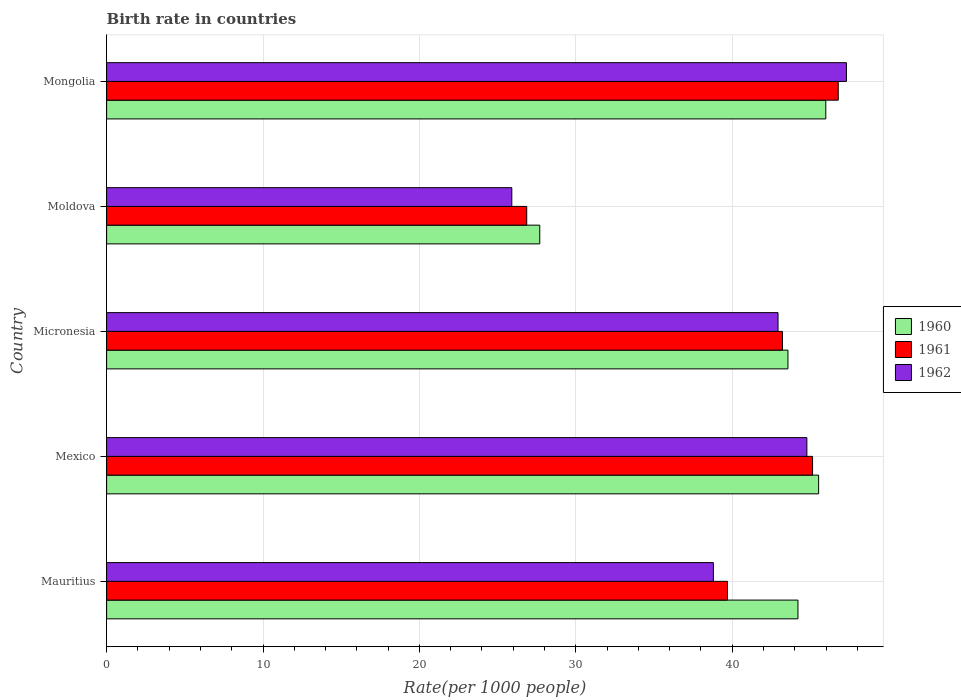How many different coloured bars are there?
Provide a short and direct response. 3. How many groups of bars are there?
Give a very brief answer. 5. What is the label of the 3rd group of bars from the top?
Your answer should be very brief. Micronesia. In how many cases, is the number of bars for a given country not equal to the number of legend labels?
Keep it short and to the point. 0. What is the birth rate in 1961 in Micronesia?
Your answer should be very brief. 43.22. Across all countries, what is the maximum birth rate in 1961?
Keep it short and to the point. 46.78. Across all countries, what is the minimum birth rate in 1961?
Offer a very short reply. 26.86. In which country was the birth rate in 1961 maximum?
Offer a terse response. Mongolia. In which country was the birth rate in 1961 minimum?
Provide a succinct answer. Moldova. What is the total birth rate in 1962 in the graph?
Offer a terse response. 199.73. What is the difference between the birth rate in 1962 in Moldova and that in Mongolia?
Make the answer very short. -21.4. What is the difference between the birth rate in 1960 in Moldova and the birth rate in 1962 in Micronesia?
Provide a succinct answer. -15.24. What is the average birth rate in 1962 per country?
Provide a short and direct response. 39.95. What is the difference between the birth rate in 1960 and birth rate in 1962 in Mexico?
Your answer should be very brief. 0.75. What is the ratio of the birth rate in 1962 in Moldova to that in Mongolia?
Your answer should be compact. 0.55. Is the difference between the birth rate in 1960 in Moldova and Mongolia greater than the difference between the birth rate in 1962 in Moldova and Mongolia?
Keep it short and to the point. Yes. What is the difference between the highest and the second highest birth rate in 1960?
Make the answer very short. 0.46. What is the difference between the highest and the lowest birth rate in 1960?
Offer a very short reply. 18.29. In how many countries, is the birth rate in 1962 greater than the average birth rate in 1962 taken over all countries?
Offer a terse response. 3. Is the sum of the birth rate in 1960 in Moldova and Mongolia greater than the maximum birth rate in 1961 across all countries?
Your answer should be very brief. Yes. How many bars are there?
Keep it short and to the point. 15. Are the values on the major ticks of X-axis written in scientific E-notation?
Provide a succinct answer. No. Does the graph contain grids?
Ensure brevity in your answer.  Yes. How many legend labels are there?
Offer a very short reply. 3. What is the title of the graph?
Make the answer very short. Birth rate in countries. What is the label or title of the X-axis?
Ensure brevity in your answer.  Rate(per 1000 people). What is the label or title of the Y-axis?
Your response must be concise. Country. What is the Rate(per 1000 people) in 1960 in Mauritius?
Your response must be concise. 44.21. What is the Rate(per 1000 people) of 1961 in Mauritius?
Your answer should be very brief. 39.7. What is the Rate(per 1000 people) of 1962 in Mauritius?
Ensure brevity in your answer.  38.8. What is the Rate(per 1000 people) of 1960 in Mexico?
Provide a short and direct response. 45.53. What is the Rate(per 1000 people) in 1961 in Mexico?
Offer a terse response. 45.14. What is the Rate(per 1000 people) in 1962 in Mexico?
Your answer should be compact. 44.78. What is the Rate(per 1000 people) in 1960 in Micronesia?
Offer a very short reply. 43.57. What is the Rate(per 1000 people) of 1961 in Micronesia?
Your answer should be compact. 43.22. What is the Rate(per 1000 people) in 1962 in Micronesia?
Give a very brief answer. 42.93. What is the Rate(per 1000 people) in 1960 in Moldova?
Your answer should be very brief. 27.7. What is the Rate(per 1000 people) in 1961 in Moldova?
Provide a short and direct response. 26.86. What is the Rate(per 1000 people) in 1962 in Moldova?
Your answer should be compact. 25.91. What is the Rate(per 1000 people) of 1960 in Mongolia?
Your answer should be compact. 45.99. What is the Rate(per 1000 people) in 1961 in Mongolia?
Offer a terse response. 46.78. What is the Rate(per 1000 people) in 1962 in Mongolia?
Your answer should be very brief. 47.31. Across all countries, what is the maximum Rate(per 1000 people) of 1960?
Your answer should be compact. 45.99. Across all countries, what is the maximum Rate(per 1000 people) of 1961?
Your response must be concise. 46.78. Across all countries, what is the maximum Rate(per 1000 people) of 1962?
Provide a succinct answer. 47.31. Across all countries, what is the minimum Rate(per 1000 people) in 1960?
Offer a very short reply. 27.7. Across all countries, what is the minimum Rate(per 1000 people) in 1961?
Your response must be concise. 26.86. Across all countries, what is the minimum Rate(per 1000 people) of 1962?
Provide a short and direct response. 25.91. What is the total Rate(per 1000 people) in 1960 in the graph?
Your answer should be compact. 206.99. What is the total Rate(per 1000 people) in 1961 in the graph?
Make the answer very short. 201.71. What is the total Rate(per 1000 people) of 1962 in the graph?
Ensure brevity in your answer.  199.73. What is the difference between the Rate(per 1000 people) of 1960 in Mauritius and that in Mexico?
Provide a short and direct response. -1.32. What is the difference between the Rate(per 1000 people) in 1961 in Mauritius and that in Mexico?
Provide a succinct answer. -5.44. What is the difference between the Rate(per 1000 people) in 1962 in Mauritius and that in Mexico?
Provide a short and direct response. -5.98. What is the difference between the Rate(per 1000 people) in 1960 in Mauritius and that in Micronesia?
Ensure brevity in your answer.  0.64. What is the difference between the Rate(per 1000 people) of 1961 in Mauritius and that in Micronesia?
Offer a very short reply. -3.52. What is the difference between the Rate(per 1000 people) in 1962 in Mauritius and that in Micronesia?
Provide a succinct answer. -4.13. What is the difference between the Rate(per 1000 people) of 1960 in Mauritius and that in Moldova?
Make the answer very short. 16.51. What is the difference between the Rate(per 1000 people) in 1961 in Mauritius and that in Moldova?
Ensure brevity in your answer.  12.84. What is the difference between the Rate(per 1000 people) in 1962 in Mauritius and that in Moldova?
Your answer should be compact. 12.89. What is the difference between the Rate(per 1000 people) of 1960 in Mauritius and that in Mongolia?
Your answer should be compact. -1.78. What is the difference between the Rate(per 1000 people) of 1961 in Mauritius and that in Mongolia?
Provide a short and direct response. -7.08. What is the difference between the Rate(per 1000 people) of 1962 in Mauritius and that in Mongolia?
Your response must be concise. -8.51. What is the difference between the Rate(per 1000 people) in 1960 in Mexico and that in Micronesia?
Keep it short and to the point. 1.96. What is the difference between the Rate(per 1000 people) of 1961 in Mexico and that in Micronesia?
Your response must be concise. 1.92. What is the difference between the Rate(per 1000 people) in 1962 in Mexico and that in Micronesia?
Offer a terse response. 1.84. What is the difference between the Rate(per 1000 people) in 1960 in Mexico and that in Moldova?
Your answer should be very brief. 17.83. What is the difference between the Rate(per 1000 people) of 1961 in Mexico and that in Moldova?
Ensure brevity in your answer.  18.28. What is the difference between the Rate(per 1000 people) of 1962 in Mexico and that in Moldova?
Make the answer very short. 18.87. What is the difference between the Rate(per 1000 people) of 1960 in Mexico and that in Mongolia?
Your answer should be very brief. -0.46. What is the difference between the Rate(per 1000 people) in 1961 in Mexico and that in Mongolia?
Your answer should be compact. -1.64. What is the difference between the Rate(per 1000 people) in 1962 in Mexico and that in Mongolia?
Provide a succinct answer. -2.53. What is the difference between the Rate(per 1000 people) of 1960 in Micronesia and that in Moldova?
Provide a short and direct response. 15.87. What is the difference between the Rate(per 1000 people) in 1961 in Micronesia and that in Moldova?
Give a very brief answer. 16.36. What is the difference between the Rate(per 1000 people) of 1962 in Micronesia and that in Moldova?
Give a very brief answer. 17.02. What is the difference between the Rate(per 1000 people) of 1960 in Micronesia and that in Mongolia?
Your answer should be compact. -2.42. What is the difference between the Rate(per 1000 people) of 1961 in Micronesia and that in Mongolia?
Keep it short and to the point. -3.56. What is the difference between the Rate(per 1000 people) of 1962 in Micronesia and that in Mongolia?
Provide a succinct answer. -4.37. What is the difference between the Rate(per 1000 people) in 1960 in Moldova and that in Mongolia?
Your answer should be very brief. -18.29. What is the difference between the Rate(per 1000 people) of 1961 in Moldova and that in Mongolia?
Keep it short and to the point. -19.92. What is the difference between the Rate(per 1000 people) of 1962 in Moldova and that in Mongolia?
Give a very brief answer. -21.4. What is the difference between the Rate(per 1000 people) in 1960 in Mauritius and the Rate(per 1000 people) in 1961 in Mexico?
Your answer should be compact. -0.93. What is the difference between the Rate(per 1000 people) in 1960 in Mauritius and the Rate(per 1000 people) in 1962 in Mexico?
Offer a terse response. -0.57. What is the difference between the Rate(per 1000 people) of 1961 in Mauritius and the Rate(per 1000 people) of 1962 in Mexico?
Offer a terse response. -5.08. What is the difference between the Rate(per 1000 people) in 1960 in Mauritius and the Rate(per 1000 people) in 1962 in Micronesia?
Offer a terse response. 1.27. What is the difference between the Rate(per 1000 people) of 1961 in Mauritius and the Rate(per 1000 people) of 1962 in Micronesia?
Your response must be concise. -3.23. What is the difference between the Rate(per 1000 people) in 1960 in Mauritius and the Rate(per 1000 people) in 1961 in Moldova?
Provide a succinct answer. 17.34. What is the difference between the Rate(per 1000 people) in 1960 in Mauritius and the Rate(per 1000 people) in 1962 in Moldova?
Your answer should be compact. 18.3. What is the difference between the Rate(per 1000 people) of 1961 in Mauritius and the Rate(per 1000 people) of 1962 in Moldova?
Offer a terse response. 13.79. What is the difference between the Rate(per 1000 people) in 1960 in Mauritius and the Rate(per 1000 people) in 1961 in Mongolia?
Provide a succinct answer. -2.58. What is the difference between the Rate(per 1000 people) in 1960 in Mauritius and the Rate(per 1000 people) in 1962 in Mongolia?
Your answer should be compact. -3.1. What is the difference between the Rate(per 1000 people) in 1961 in Mauritius and the Rate(per 1000 people) in 1962 in Mongolia?
Provide a succinct answer. -7.61. What is the difference between the Rate(per 1000 people) in 1960 in Mexico and the Rate(per 1000 people) in 1961 in Micronesia?
Keep it short and to the point. 2.31. What is the difference between the Rate(per 1000 people) in 1960 in Mexico and the Rate(per 1000 people) in 1962 in Micronesia?
Your answer should be compact. 2.6. What is the difference between the Rate(per 1000 people) in 1961 in Mexico and the Rate(per 1000 people) in 1962 in Micronesia?
Provide a succinct answer. 2.21. What is the difference between the Rate(per 1000 people) in 1960 in Mexico and the Rate(per 1000 people) in 1961 in Moldova?
Offer a very short reply. 18.67. What is the difference between the Rate(per 1000 people) in 1960 in Mexico and the Rate(per 1000 people) in 1962 in Moldova?
Provide a succinct answer. 19.62. What is the difference between the Rate(per 1000 people) of 1961 in Mexico and the Rate(per 1000 people) of 1962 in Moldova?
Give a very brief answer. 19.23. What is the difference between the Rate(per 1000 people) of 1960 in Mexico and the Rate(per 1000 people) of 1961 in Mongolia?
Keep it short and to the point. -1.25. What is the difference between the Rate(per 1000 people) of 1960 in Mexico and the Rate(per 1000 people) of 1962 in Mongolia?
Provide a short and direct response. -1.78. What is the difference between the Rate(per 1000 people) of 1961 in Mexico and the Rate(per 1000 people) of 1962 in Mongolia?
Make the answer very short. -2.17. What is the difference between the Rate(per 1000 people) of 1960 in Micronesia and the Rate(per 1000 people) of 1961 in Moldova?
Make the answer very short. 16.7. What is the difference between the Rate(per 1000 people) of 1960 in Micronesia and the Rate(per 1000 people) of 1962 in Moldova?
Offer a very short reply. 17.66. What is the difference between the Rate(per 1000 people) in 1961 in Micronesia and the Rate(per 1000 people) in 1962 in Moldova?
Ensure brevity in your answer.  17.31. What is the difference between the Rate(per 1000 people) of 1960 in Micronesia and the Rate(per 1000 people) of 1961 in Mongolia?
Ensure brevity in your answer.  -3.22. What is the difference between the Rate(per 1000 people) in 1960 in Micronesia and the Rate(per 1000 people) in 1962 in Mongolia?
Provide a succinct answer. -3.74. What is the difference between the Rate(per 1000 people) in 1961 in Micronesia and the Rate(per 1000 people) in 1962 in Mongolia?
Keep it short and to the point. -4.09. What is the difference between the Rate(per 1000 people) of 1960 in Moldova and the Rate(per 1000 people) of 1961 in Mongolia?
Offer a very short reply. -19.09. What is the difference between the Rate(per 1000 people) in 1960 in Moldova and the Rate(per 1000 people) in 1962 in Mongolia?
Keep it short and to the point. -19.61. What is the difference between the Rate(per 1000 people) in 1961 in Moldova and the Rate(per 1000 people) in 1962 in Mongolia?
Give a very brief answer. -20.44. What is the average Rate(per 1000 people) in 1960 per country?
Provide a short and direct response. 41.4. What is the average Rate(per 1000 people) in 1961 per country?
Ensure brevity in your answer.  40.34. What is the average Rate(per 1000 people) in 1962 per country?
Offer a terse response. 39.95. What is the difference between the Rate(per 1000 people) of 1960 and Rate(per 1000 people) of 1961 in Mauritius?
Make the answer very short. 4.51. What is the difference between the Rate(per 1000 people) in 1960 and Rate(per 1000 people) in 1962 in Mauritius?
Give a very brief answer. 5.41. What is the difference between the Rate(per 1000 people) in 1961 and Rate(per 1000 people) in 1962 in Mauritius?
Provide a succinct answer. 0.9. What is the difference between the Rate(per 1000 people) in 1960 and Rate(per 1000 people) in 1961 in Mexico?
Provide a short and direct response. 0.39. What is the difference between the Rate(per 1000 people) in 1960 and Rate(per 1000 people) in 1962 in Mexico?
Make the answer very short. 0.75. What is the difference between the Rate(per 1000 people) in 1961 and Rate(per 1000 people) in 1962 in Mexico?
Your answer should be compact. 0.36. What is the difference between the Rate(per 1000 people) in 1960 and Rate(per 1000 people) in 1961 in Micronesia?
Keep it short and to the point. 0.35. What is the difference between the Rate(per 1000 people) in 1960 and Rate(per 1000 people) in 1962 in Micronesia?
Provide a short and direct response. 0.63. What is the difference between the Rate(per 1000 people) in 1961 and Rate(per 1000 people) in 1962 in Micronesia?
Your answer should be compact. 0.28. What is the difference between the Rate(per 1000 people) in 1960 and Rate(per 1000 people) in 1961 in Moldova?
Your answer should be compact. 0.83. What is the difference between the Rate(per 1000 people) in 1960 and Rate(per 1000 people) in 1962 in Moldova?
Ensure brevity in your answer.  1.79. What is the difference between the Rate(per 1000 people) of 1961 and Rate(per 1000 people) of 1962 in Moldova?
Provide a short and direct response. 0.95. What is the difference between the Rate(per 1000 people) of 1960 and Rate(per 1000 people) of 1961 in Mongolia?
Offer a terse response. -0.8. What is the difference between the Rate(per 1000 people) in 1960 and Rate(per 1000 people) in 1962 in Mongolia?
Offer a terse response. -1.32. What is the difference between the Rate(per 1000 people) in 1961 and Rate(per 1000 people) in 1962 in Mongolia?
Your response must be concise. -0.52. What is the ratio of the Rate(per 1000 people) of 1961 in Mauritius to that in Mexico?
Make the answer very short. 0.88. What is the ratio of the Rate(per 1000 people) in 1962 in Mauritius to that in Mexico?
Offer a very short reply. 0.87. What is the ratio of the Rate(per 1000 people) of 1960 in Mauritius to that in Micronesia?
Provide a succinct answer. 1.01. What is the ratio of the Rate(per 1000 people) of 1961 in Mauritius to that in Micronesia?
Your answer should be compact. 0.92. What is the ratio of the Rate(per 1000 people) of 1962 in Mauritius to that in Micronesia?
Offer a very short reply. 0.9. What is the ratio of the Rate(per 1000 people) of 1960 in Mauritius to that in Moldova?
Provide a succinct answer. 1.6. What is the ratio of the Rate(per 1000 people) of 1961 in Mauritius to that in Moldova?
Provide a succinct answer. 1.48. What is the ratio of the Rate(per 1000 people) in 1962 in Mauritius to that in Moldova?
Offer a terse response. 1.5. What is the ratio of the Rate(per 1000 people) in 1960 in Mauritius to that in Mongolia?
Offer a very short reply. 0.96. What is the ratio of the Rate(per 1000 people) of 1961 in Mauritius to that in Mongolia?
Offer a terse response. 0.85. What is the ratio of the Rate(per 1000 people) of 1962 in Mauritius to that in Mongolia?
Ensure brevity in your answer.  0.82. What is the ratio of the Rate(per 1000 people) in 1960 in Mexico to that in Micronesia?
Give a very brief answer. 1.04. What is the ratio of the Rate(per 1000 people) of 1961 in Mexico to that in Micronesia?
Your answer should be very brief. 1.04. What is the ratio of the Rate(per 1000 people) of 1962 in Mexico to that in Micronesia?
Offer a very short reply. 1.04. What is the ratio of the Rate(per 1000 people) in 1960 in Mexico to that in Moldova?
Provide a succinct answer. 1.64. What is the ratio of the Rate(per 1000 people) in 1961 in Mexico to that in Moldova?
Offer a terse response. 1.68. What is the ratio of the Rate(per 1000 people) in 1962 in Mexico to that in Moldova?
Provide a short and direct response. 1.73. What is the ratio of the Rate(per 1000 people) of 1961 in Mexico to that in Mongolia?
Ensure brevity in your answer.  0.96. What is the ratio of the Rate(per 1000 people) in 1962 in Mexico to that in Mongolia?
Your answer should be very brief. 0.95. What is the ratio of the Rate(per 1000 people) in 1960 in Micronesia to that in Moldova?
Your response must be concise. 1.57. What is the ratio of the Rate(per 1000 people) in 1961 in Micronesia to that in Moldova?
Ensure brevity in your answer.  1.61. What is the ratio of the Rate(per 1000 people) of 1962 in Micronesia to that in Moldova?
Provide a short and direct response. 1.66. What is the ratio of the Rate(per 1000 people) of 1961 in Micronesia to that in Mongolia?
Offer a terse response. 0.92. What is the ratio of the Rate(per 1000 people) in 1962 in Micronesia to that in Mongolia?
Your answer should be compact. 0.91. What is the ratio of the Rate(per 1000 people) of 1960 in Moldova to that in Mongolia?
Keep it short and to the point. 0.6. What is the ratio of the Rate(per 1000 people) in 1961 in Moldova to that in Mongolia?
Offer a very short reply. 0.57. What is the ratio of the Rate(per 1000 people) in 1962 in Moldova to that in Mongolia?
Ensure brevity in your answer.  0.55. What is the difference between the highest and the second highest Rate(per 1000 people) of 1960?
Provide a short and direct response. 0.46. What is the difference between the highest and the second highest Rate(per 1000 people) in 1961?
Provide a succinct answer. 1.64. What is the difference between the highest and the second highest Rate(per 1000 people) of 1962?
Provide a succinct answer. 2.53. What is the difference between the highest and the lowest Rate(per 1000 people) of 1960?
Your answer should be very brief. 18.29. What is the difference between the highest and the lowest Rate(per 1000 people) in 1961?
Offer a very short reply. 19.92. What is the difference between the highest and the lowest Rate(per 1000 people) of 1962?
Offer a terse response. 21.4. 